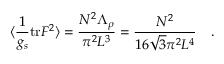<formula> <loc_0><loc_0><loc_500><loc_500>\langle \frac { 1 } { g _ { s } } t r F ^ { 2 } \rangle = \frac { N ^ { 2 } \Lambda _ { \rho } } { \pi ^ { 2 } L ^ { 3 } } = \frac { N ^ { 2 } } { 1 6 \sqrt { 3 } \pi ^ { 2 } L ^ { 4 } } \quad .</formula> 